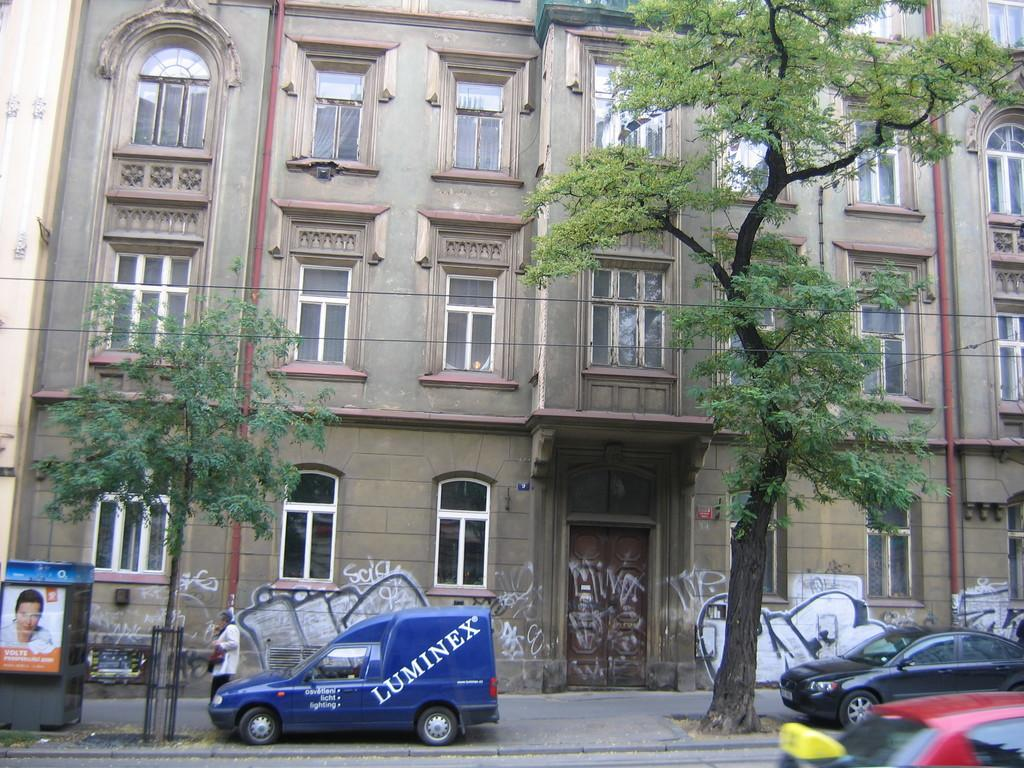<image>
Render a clear and concise summary of the photo. A  blue Luminex van is parked on the street in front a graffiti covered building. 